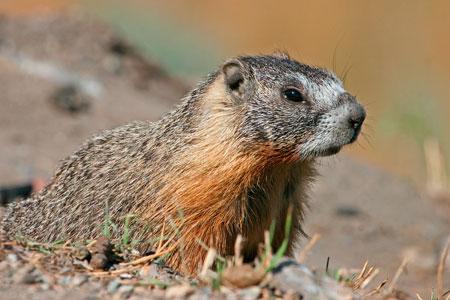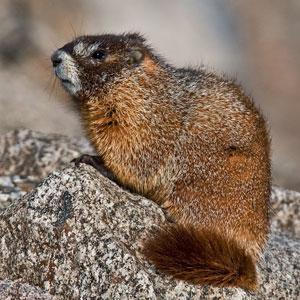The first image is the image on the left, the second image is the image on the right. For the images shown, is this caption "In one of the images, there is a marmot standing up on its hind legs" true? Answer yes or no. No. 